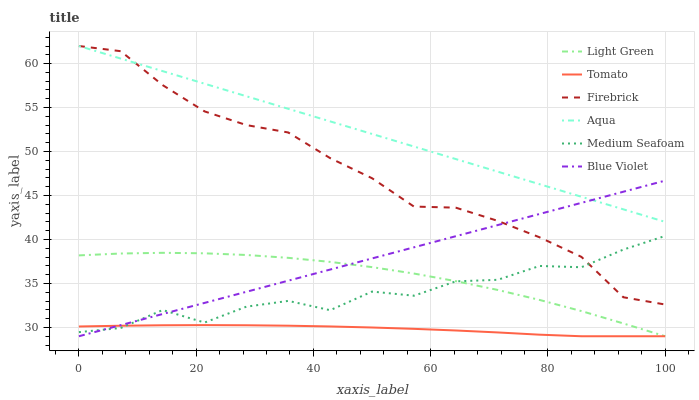Does Tomato have the minimum area under the curve?
Answer yes or no. Yes. Does Aqua have the maximum area under the curve?
Answer yes or no. Yes. Does Firebrick have the minimum area under the curve?
Answer yes or no. No. Does Firebrick have the maximum area under the curve?
Answer yes or no. No. Is Blue Violet the smoothest?
Answer yes or no. Yes. Is Medium Seafoam the roughest?
Answer yes or no. Yes. Is Firebrick the smoothest?
Answer yes or no. No. Is Firebrick the roughest?
Answer yes or no. No. Does Firebrick have the lowest value?
Answer yes or no. No. Does Aqua have the highest value?
Answer yes or no. Yes. Does Light Green have the highest value?
Answer yes or no. No. Is Light Green less than Firebrick?
Answer yes or no. Yes. Is Aqua greater than Light Green?
Answer yes or no. Yes. Does Blue Violet intersect Tomato?
Answer yes or no. Yes. Is Blue Violet less than Tomato?
Answer yes or no. No. Is Blue Violet greater than Tomato?
Answer yes or no. No. Does Light Green intersect Firebrick?
Answer yes or no. No. 